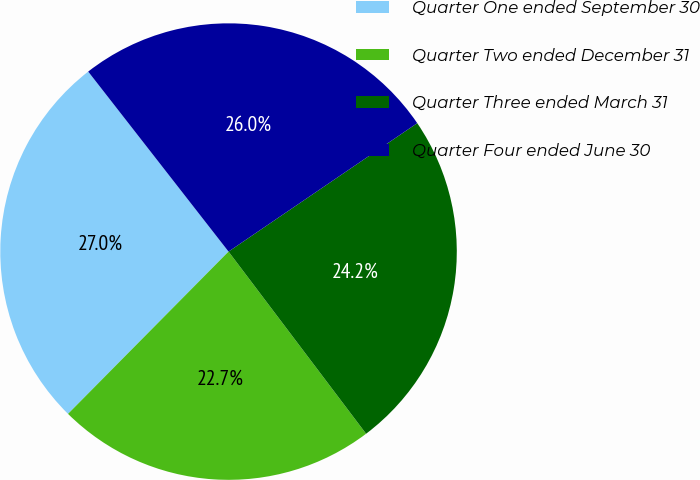Convert chart to OTSL. <chart><loc_0><loc_0><loc_500><loc_500><pie_chart><fcel>Quarter One ended September 30<fcel>Quarter Two ended December 31<fcel>Quarter Three ended March 31<fcel>Quarter Four ended June 30<nl><fcel>27.05%<fcel>22.71%<fcel>24.22%<fcel>26.03%<nl></chart> 